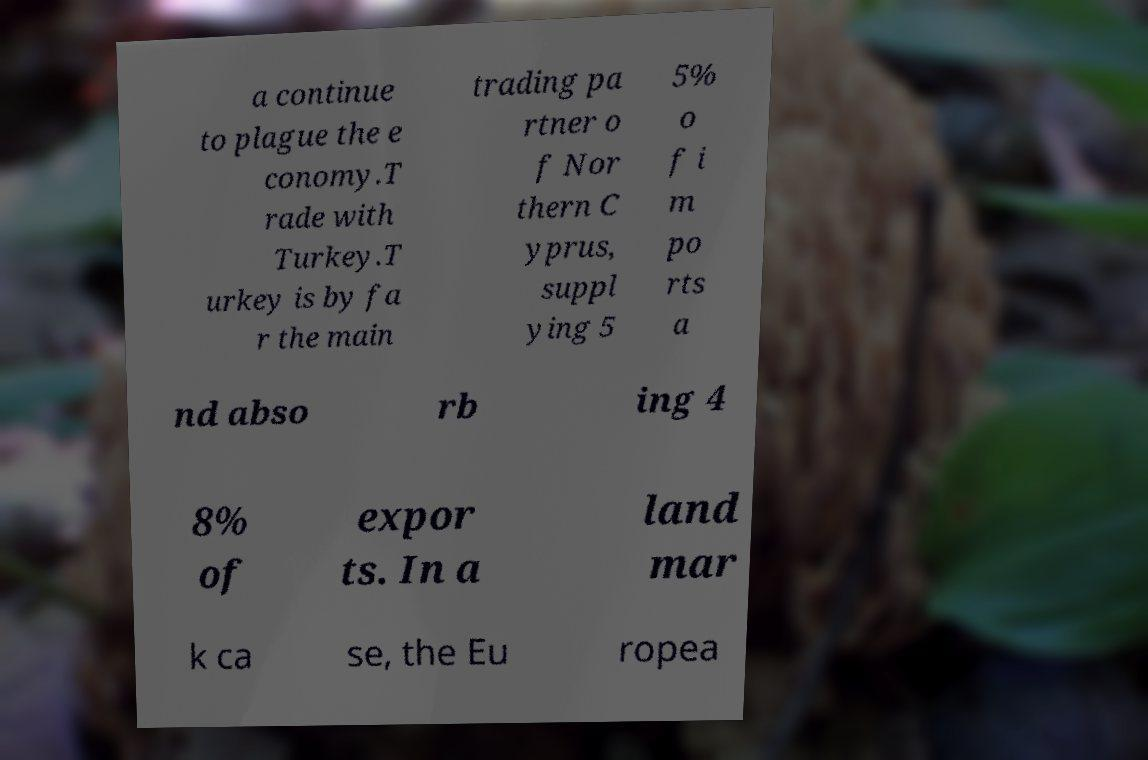I need the written content from this picture converted into text. Can you do that? a continue to plague the e conomy.T rade with Turkey.T urkey is by fa r the main trading pa rtner o f Nor thern C yprus, suppl ying 5 5% o f i m po rts a nd abso rb ing 4 8% of expor ts. In a land mar k ca se, the Eu ropea 